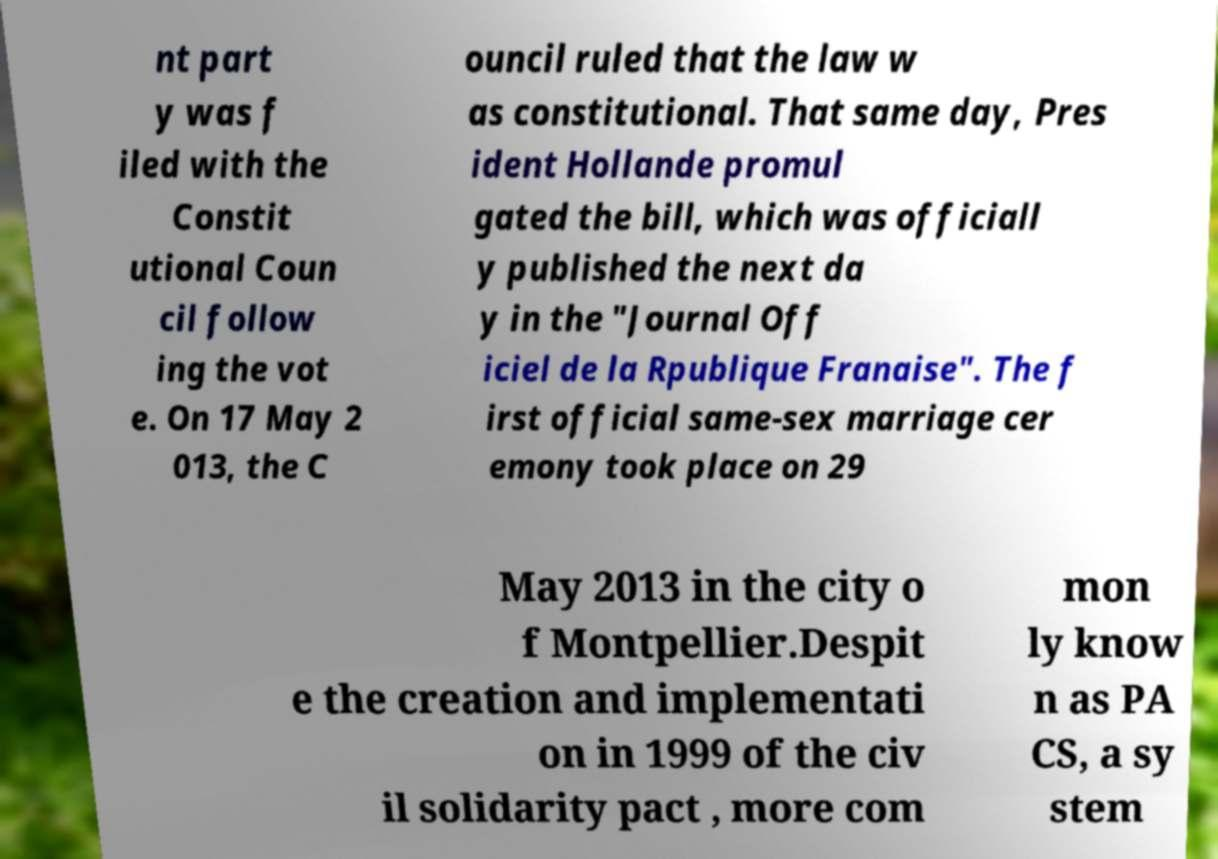There's text embedded in this image that I need extracted. Can you transcribe it verbatim? nt part y was f iled with the Constit utional Coun cil follow ing the vot e. On 17 May 2 013, the C ouncil ruled that the law w as constitutional. That same day, Pres ident Hollande promul gated the bill, which was officiall y published the next da y in the "Journal Off iciel de la Rpublique Franaise". The f irst official same-sex marriage cer emony took place on 29 May 2013 in the city o f Montpellier.Despit e the creation and implementati on in 1999 of the civ il solidarity pact , more com mon ly know n as PA CS, a sy stem 